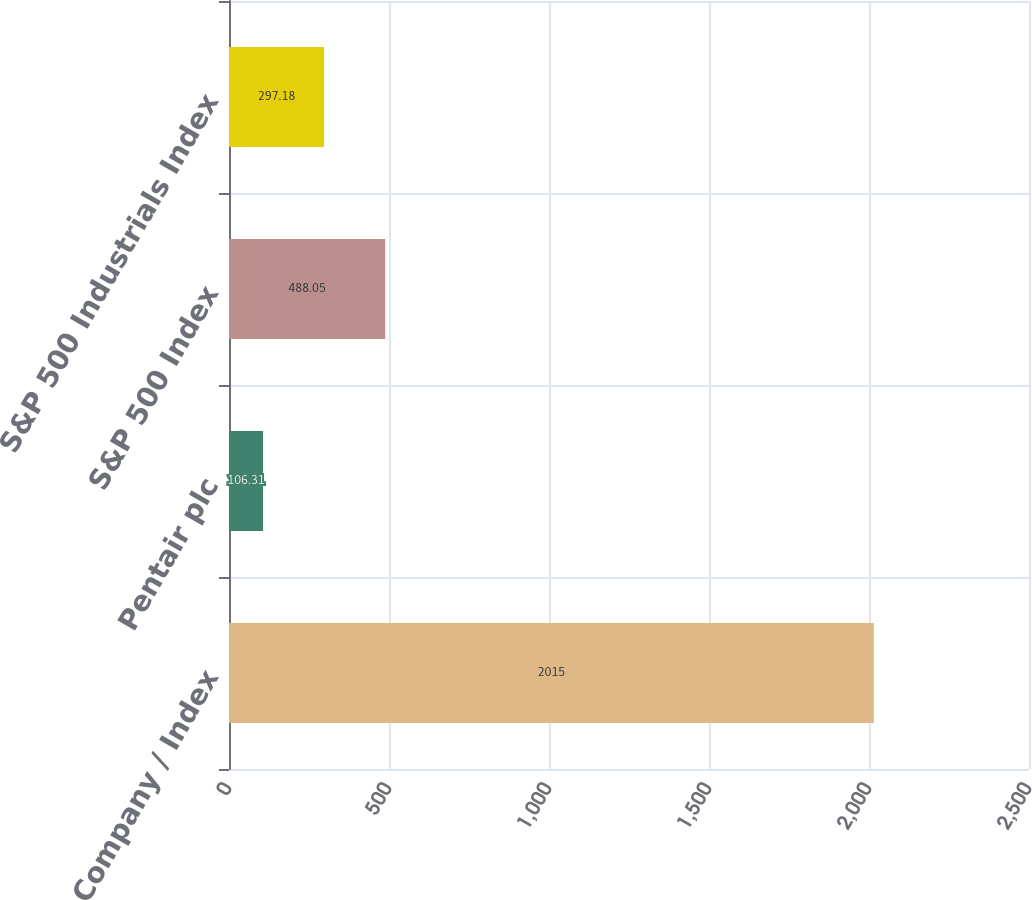Convert chart to OTSL. <chart><loc_0><loc_0><loc_500><loc_500><bar_chart><fcel>Company / Index<fcel>Pentair plc<fcel>S&P 500 Index<fcel>S&P 500 Industrials Index<nl><fcel>2015<fcel>106.31<fcel>488.05<fcel>297.18<nl></chart> 